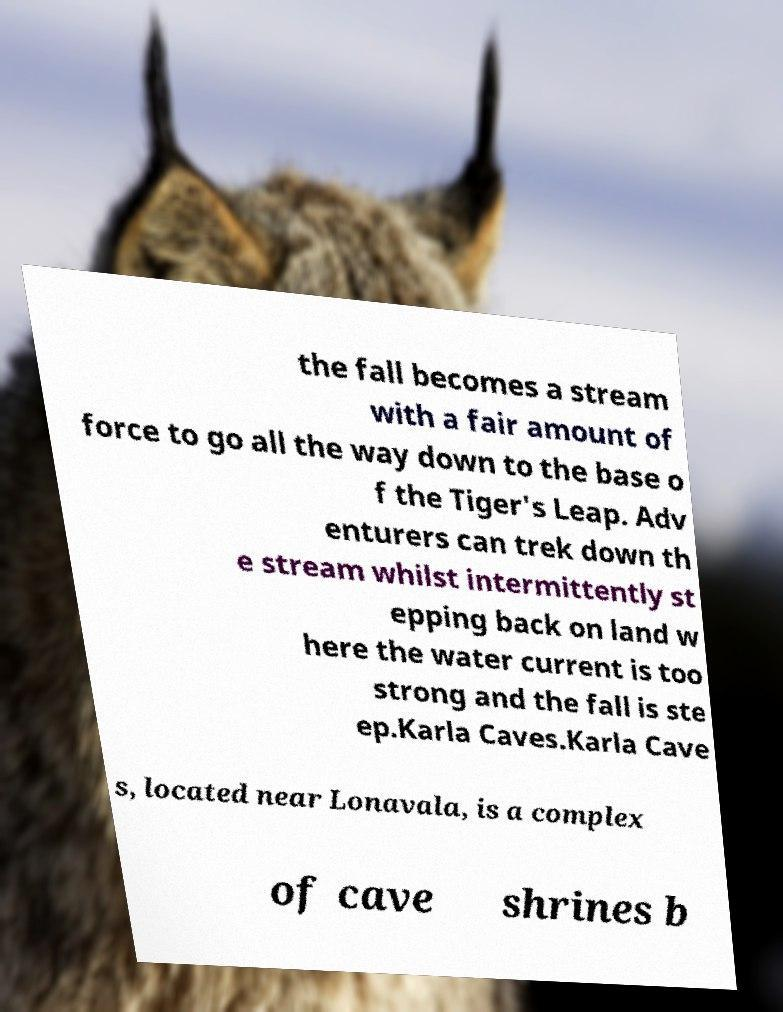Please identify and transcribe the text found in this image. the fall becomes a stream with a fair amount of force to go all the way down to the base o f the Tiger's Leap. Adv enturers can trek down th e stream whilst intermittently st epping back on land w here the water current is too strong and the fall is ste ep.Karla Caves.Karla Cave s, located near Lonavala, is a complex of cave shrines b 